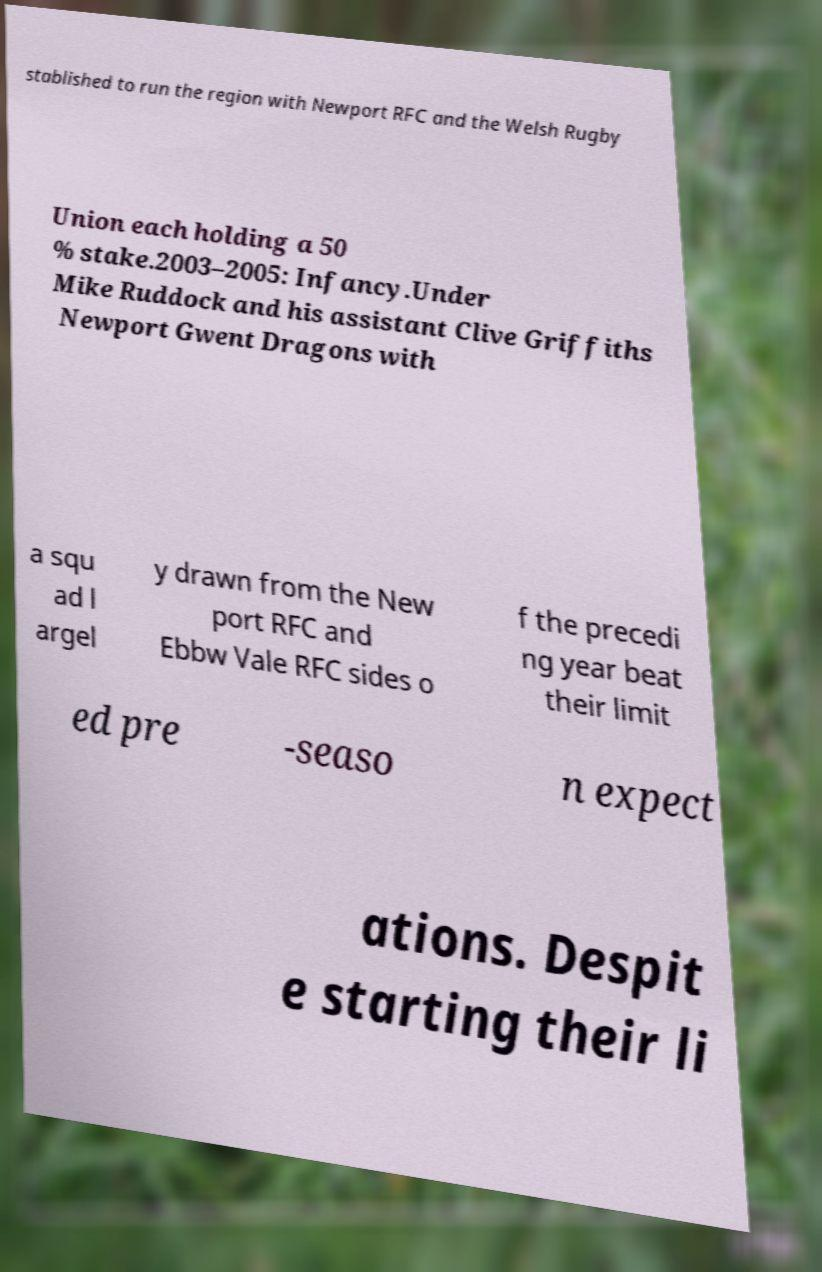What messages or text are displayed in this image? I need them in a readable, typed format. stablished to run the region with Newport RFC and the Welsh Rugby Union each holding a 50 % stake.2003–2005: Infancy.Under Mike Ruddock and his assistant Clive Griffiths Newport Gwent Dragons with a squ ad l argel y drawn from the New port RFC and Ebbw Vale RFC sides o f the precedi ng year beat their limit ed pre -seaso n expect ations. Despit e starting their li 